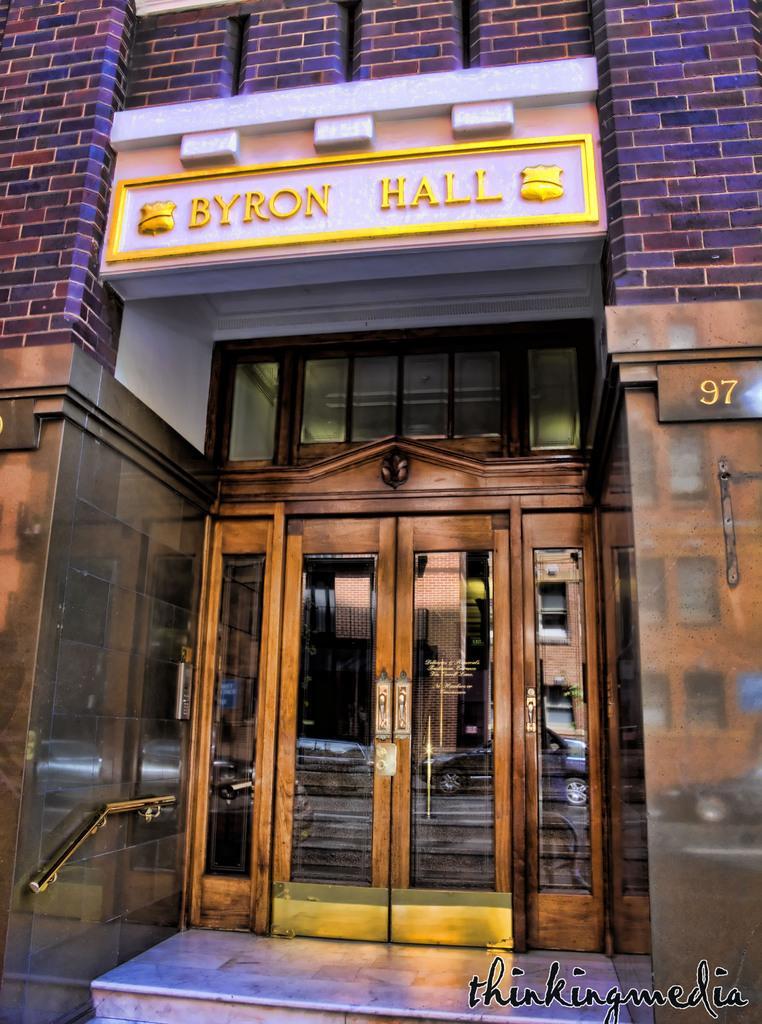In one or two sentences, can you explain what this image depicts? In this image we can see the front view of the building. Door and banner is present. 